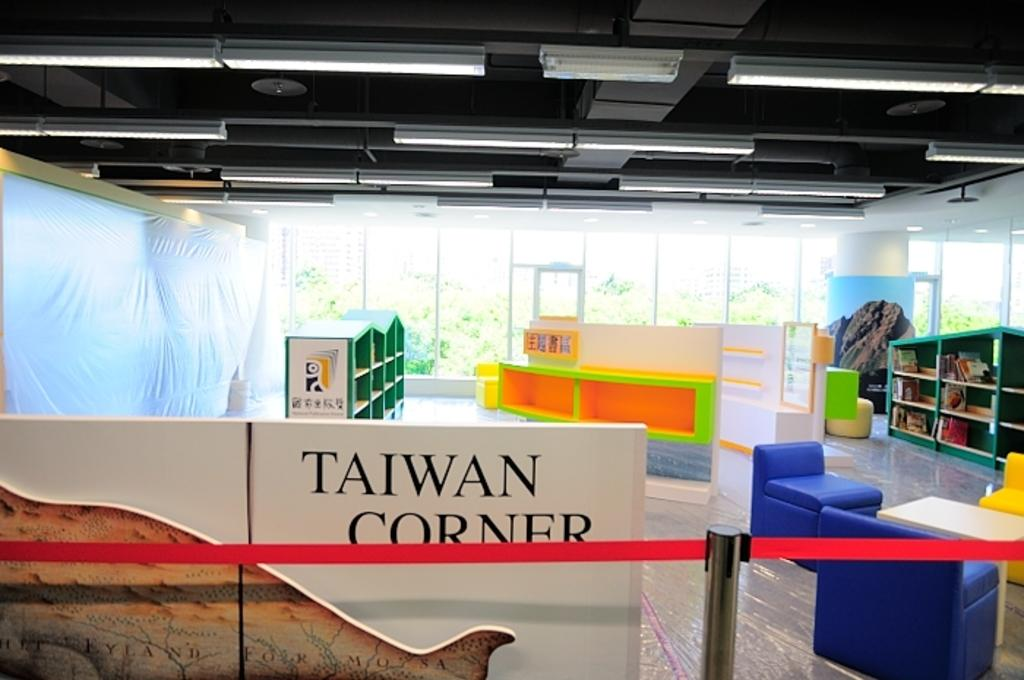Provide a one-sentence caption for the provided image. Taiwan corner in a museum with bright color book shelves. 